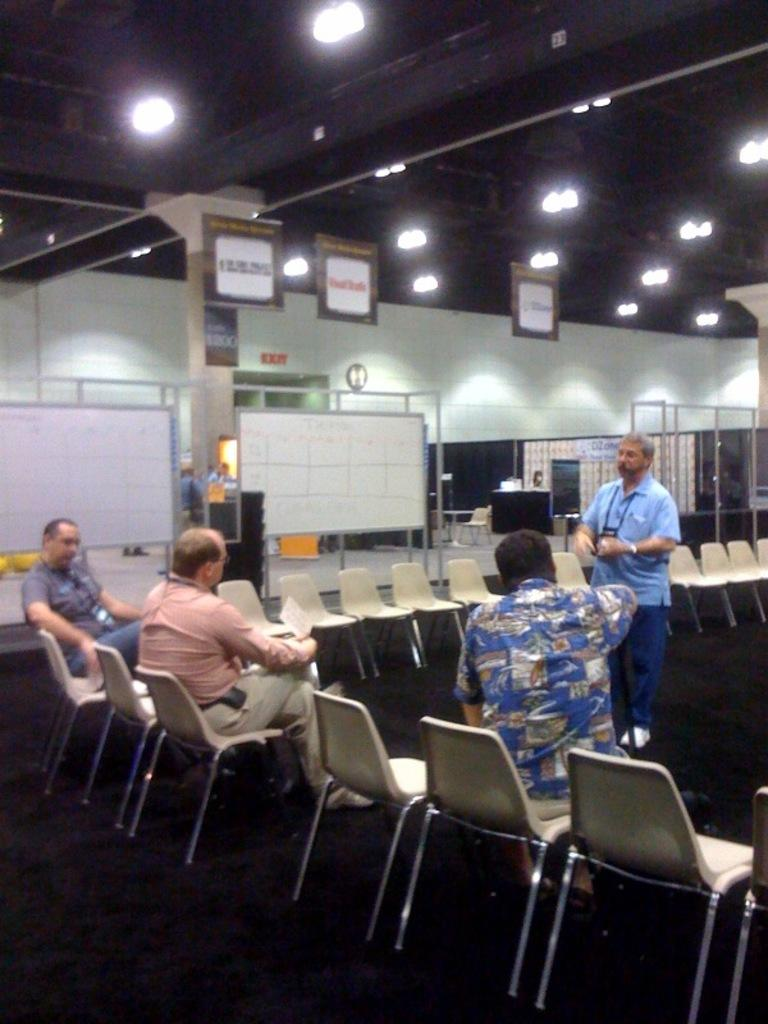How many persons are sitting in the image? There are three persons sitting on chairs in the image. What is the position of the person behind the seated persons? There is a person standing behind the seated persons. What can be seen in the background of the image? In the background of the image, there are boards, lights, the ceiling, a pillar, and a wall. Can you describe the setting of the image? The image appears to be set in a room with chairs, a standing person, and various background elements. What type of pie is being served on the table in the image? There is no table or pie present in the image; it features three seated persons and a standing person in a room with various background elements. 